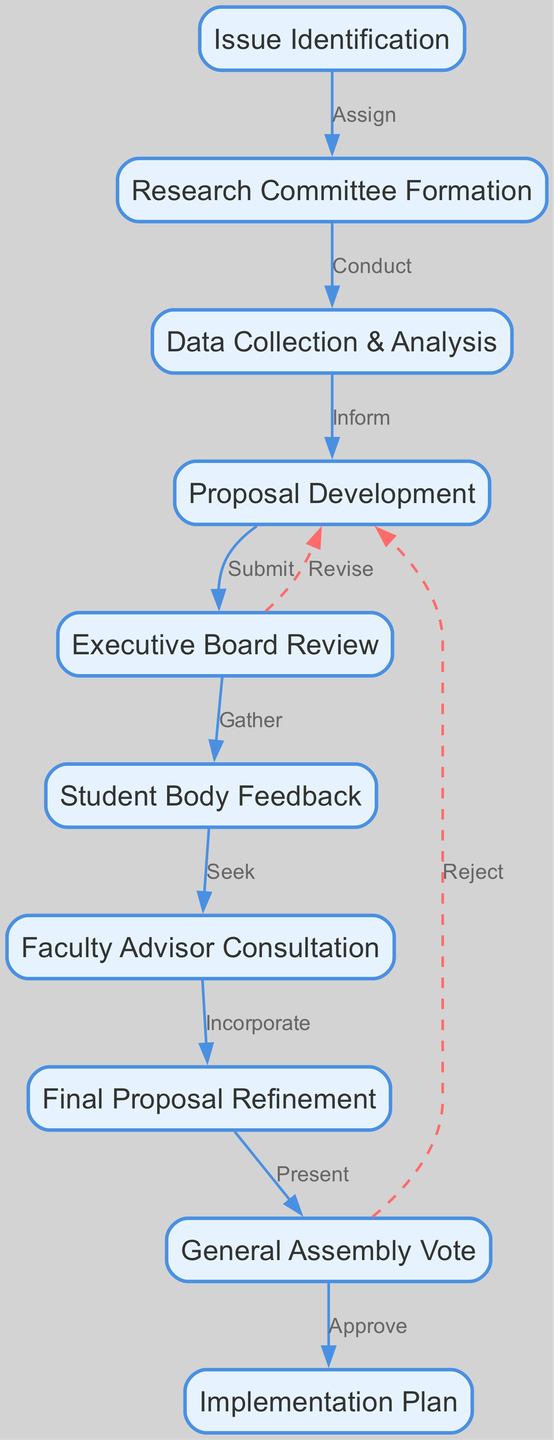What is the first node in the decision-making process? The first node in the diagram is 'Issue Identification', which is represented as the starting point of the flowchart indicating where the process begins.
Answer: Issue Identification How many nodes are present in the diagram? By counting the nodes listed in the data provided, there are a total of ten distinct nodes in the diagram representing various steps in the decision-making process.
Answer: 10 What is the purpose of the 'Research Committee Formation' node? The purpose of the 'Research Committee Formation' node is to establish a group tasked with conducting research, as it is directly after 'Issue Identification', implying its role in the next stage of the process.
Answer: Form a research committee Which node follows 'Data Collection & Analysis'? The node that follows 'Data Collection & Analysis' is 'Proposal Development', indicating the flow from analyzing data into developing a formal proposal based on the findings.
Answer: Proposal Development What action is taken after 'Executive Board Review'? After the 'Executive Board Review', the action taken is 'Student Body Feedback', suggesting that input from the broader student body is sought before moving forward in the process.
Answer: Gather student feedback How many edges are there in total? By counting the number of connections (edges) described in the data, there are thirteen edges in total that illustrate the relationships and flow between the various nodes in the decision-making process.
Answer: 13 What does the dashed line between 'Executive Board Review' and 'Proposal Development' indicate? The dashed line indicates a revision process, suggesting that the proposal can be revisited and altered based on the feedback or findings from the review before it is submitted again.
Answer: Revise proposal What is the final node of the decision-making process? The final node in the diagram is 'Implementation Plan', which signifies the last step where an approved plan is put into action following a successful vote in the general assembly.
Answer: Implementation Plan What does the edge from 'General Assembly Vote' to 'Implementation Plan' signify? This edge signifies that after the general assembly votes on the proposal, if approved, it leads directly to the creation of an implementation plan to execute the decisions made.
Answer: Approve implementation plan 